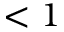Convert formula to latex. <formula><loc_0><loc_0><loc_500><loc_500>< 1</formula> 